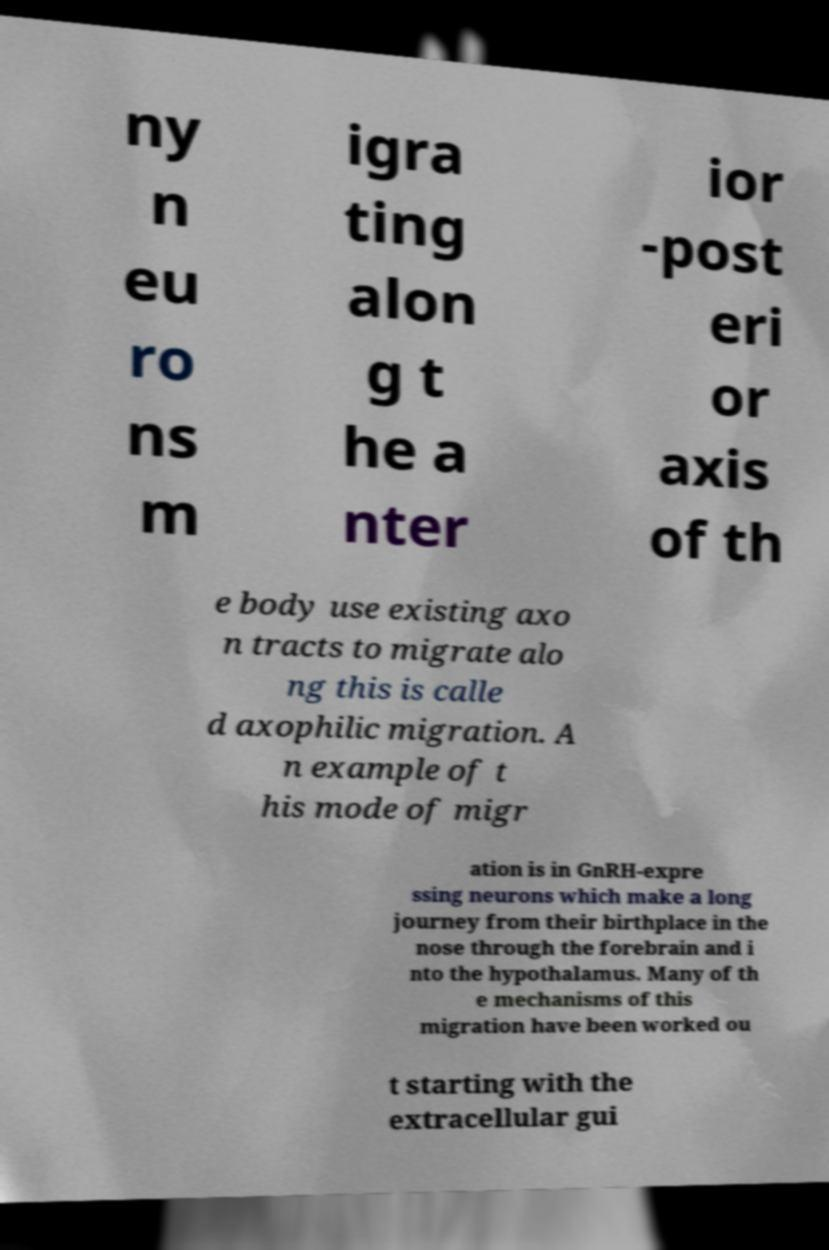What messages or text are displayed in this image? I need them in a readable, typed format. ny n eu ro ns m igra ting alon g t he a nter ior -post eri or axis of th e body use existing axo n tracts to migrate alo ng this is calle d axophilic migration. A n example of t his mode of migr ation is in GnRH-expre ssing neurons which make a long journey from their birthplace in the nose through the forebrain and i nto the hypothalamus. Many of th e mechanisms of this migration have been worked ou t starting with the extracellular gui 